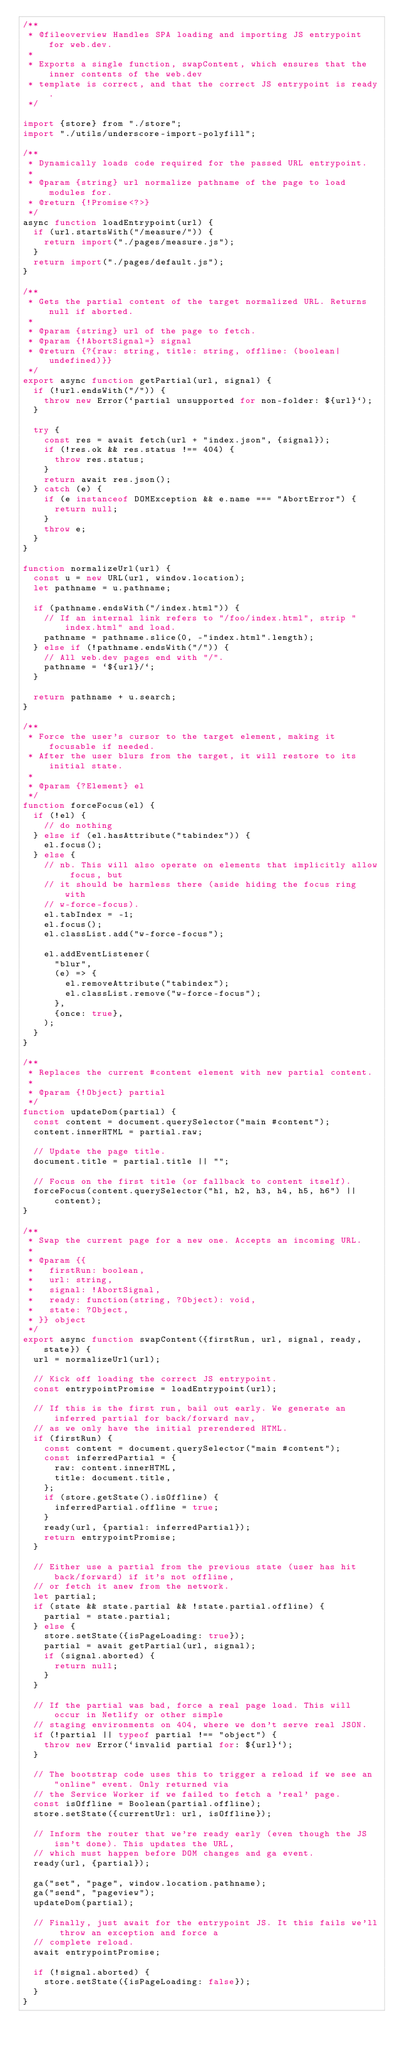<code> <loc_0><loc_0><loc_500><loc_500><_JavaScript_>/**
 * @fileoverview Handles SPA loading and importing JS entrypoint for web.dev.
 *
 * Exports a single function, swapContent, which ensures that the inner contents of the web.dev
 * template is correct, and that the correct JS entrypoint is ready.
 */

import {store} from "./store";
import "./utils/underscore-import-polyfill";

/**
 * Dynamically loads code required for the passed URL entrypoint.
 *
 * @param {string} url normalize pathname of the page to load modules for.
 * @return {!Promise<?>}
 */
async function loadEntrypoint(url) {
  if (url.startsWith("/measure/")) {
    return import("./pages/measure.js");
  }
  return import("./pages/default.js");
}

/**
 * Gets the partial content of the target normalized URL. Returns null if aborted.
 *
 * @param {string} url of the page to fetch.
 * @param {!AbortSignal=} signal
 * @return {?{raw: string, title: string, offline: (boolean|undefined)}}
 */
export async function getPartial(url, signal) {
  if (!url.endsWith("/")) {
    throw new Error(`partial unsupported for non-folder: ${url}`);
  }

  try {
    const res = await fetch(url + "index.json", {signal});
    if (!res.ok && res.status !== 404) {
      throw res.status;
    }
    return await res.json();
  } catch (e) {
    if (e instanceof DOMException && e.name === "AbortError") {
      return null;
    }
    throw e;
  }
}

function normalizeUrl(url) {
  const u = new URL(url, window.location);
  let pathname = u.pathname;

  if (pathname.endsWith("/index.html")) {
    // If an internal link refers to "/foo/index.html", strip "index.html" and load.
    pathname = pathname.slice(0, -"index.html".length);
  } else if (!pathname.endsWith("/")) {
    // All web.dev pages end with "/".
    pathname = `${url}/`;
  }

  return pathname + u.search;
}

/**
 * Force the user's cursor to the target element, making it focusable if needed.
 * After the user blurs from the target, it will restore to its initial state.
 *
 * @param {?Element} el
 */
function forceFocus(el) {
  if (!el) {
    // do nothing
  } else if (el.hasAttribute("tabindex")) {
    el.focus();
  } else {
    // nb. This will also operate on elements that implicitly allow focus, but
    // it should be harmless there (aside hiding the focus ring with
    // w-force-focus).
    el.tabIndex = -1;
    el.focus();
    el.classList.add("w-force-focus");

    el.addEventListener(
      "blur",
      (e) => {
        el.removeAttribute("tabindex");
        el.classList.remove("w-force-focus");
      },
      {once: true},
    );
  }
}

/**
 * Replaces the current #content element with new partial content.
 *
 * @param {!Object} partial
 */
function updateDom(partial) {
  const content = document.querySelector("main #content");
  content.innerHTML = partial.raw;

  // Update the page title.
  document.title = partial.title || "";

  // Focus on the first title (or fallback to content itself).
  forceFocus(content.querySelector("h1, h2, h3, h4, h5, h6") || content);
}

/**
 * Swap the current page for a new one. Accepts an incoming URL.
 *
 * @param {{
 *   firstRun: boolean,
 *   url: string,
 *   signal: !AbortSignal,
 *   ready: function(string, ?Object): void,
 *   state: ?Object,
 * }} object
 */
export async function swapContent({firstRun, url, signal, ready, state}) {
  url = normalizeUrl(url);

  // Kick off loading the correct JS entrypoint.
  const entrypointPromise = loadEntrypoint(url);

  // If this is the first run, bail out early. We generate an inferred partial for back/forward nav,
  // as we only have the initial prerendered HTML.
  if (firstRun) {
    const content = document.querySelector("main #content");
    const inferredPartial = {
      raw: content.innerHTML,
      title: document.title,
    };
    if (store.getState().isOffline) {
      inferredPartial.offline = true;
    }
    ready(url, {partial: inferredPartial});
    return entrypointPromise;
  }

  // Either use a partial from the previous state (user has hit back/forward) if it's not offline,
  // or fetch it anew from the network.
  let partial;
  if (state && state.partial && !state.partial.offline) {
    partial = state.partial;
  } else {
    store.setState({isPageLoading: true});
    partial = await getPartial(url, signal);
    if (signal.aborted) {
      return null;
    }
  }

  // If the partial was bad, force a real page load. This will occur in Netlify or other simple
  // staging environments on 404, where we don't serve real JSON.
  if (!partial || typeof partial !== "object") {
    throw new Error(`invalid partial for: ${url}`);
  }

  // The bootstrap code uses this to trigger a reload if we see an "online" event. Only returned via
  // the Service Worker if we failed to fetch a 'real' page.
  const isOffline = Boolean(partial.offline);
  store.setState({currentUrl: url, isOffline});

  // Inform the router that we're ready early (even though the JS isn't done). This updates the URL,
  // which must happen before DOM changes and ga event.
  ready(url, {partial});

  ga("set", "page", window.location.pathname);
  ga("send", "pageview");
  updateDom(partial);

  // Finally, just await for the entrypoint JS. It this fails we'll throw an exception and force a
  // complete reload.
  await entrypointPromise;

  if (!signal.aborted) {
    store.setState({isPageLoading: false});
  }
}
</code> 